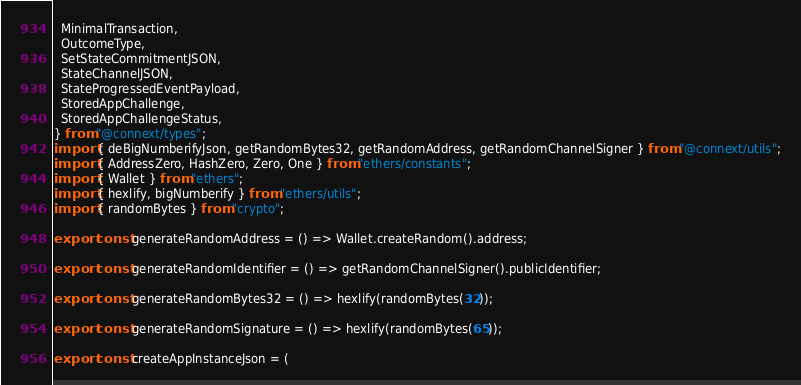<code> <loc_0><loc_0><loc_500><loc_500><_TypeScript_>  MinimalTransaction,
  OutcomeType,
  SetStateCommitmentJSON,
  StateChannelJSON,
  StateProgressedEventPayload,
  StoredAppChallenge,
  StoredAppChallengeStatus,
} from "@connext/types";
import { deBigNumberifyJson, getRandomBytes32, getRandomAddress, getRandomChannelSigner } from "@connext/utils";
import { AddressZero, HashZero, Zero, One } from "ethers/constants";
import { Wallet } from "ethers";
import { hexlify, bigNumberify } from "ethers/utils";
import { randomBytes } from "crypto";

export const generateRandomAddress = () => Wallet.createRandom().address;

export const generateRandomIdentifier = () => getRandomChannelSigner().publicIdentifier;

export const generateRandomBytes32 = () => hexlify(randomBytes(32));

export const generateRandomSignature = () => hexlify(randomBytes(65));

export const createAppInstanceJson = (</code> 